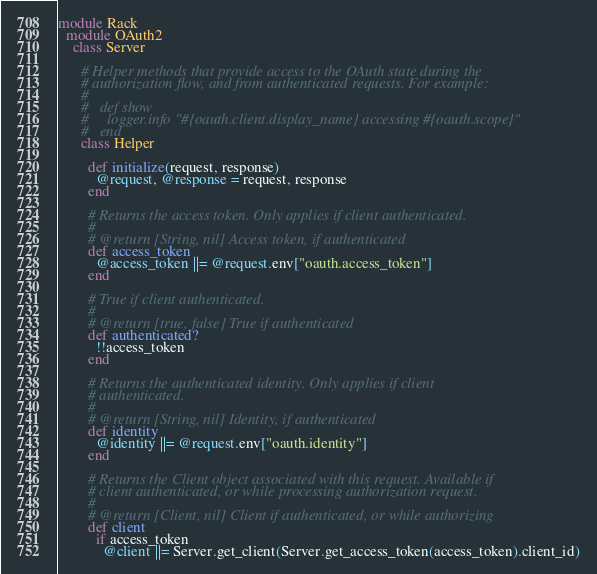<code> <loc_0><loc_0><loc_500><loc_500><_Ruby_>module Rack
  module OAuth2
    class Server

      # Helper methods that provide access to the OAuth state during the
      # authorization flow, and from authenticated requests. For example:
      #
      #   def show
      #     logger.info "#{oauth.client.display_name} accessing #{oauth.scope}"
      #   end
      class Helper

        def initialize(request, response)
          @request, @response = request, response
        end

        # Returns the access token. Only applies if client authenticated.
        #
        # @return [String, nil] Access token, if authenticated
        def access_token
          @access_token ||= @request.env["oauth.access_token"]
        end

        # True if client authenticated.
        #
        # @return [true, false] True if authenticated
        def authenticated?
          !!access_token
        end

        # Returns the authenticated identity. Only applies if client
        # authenticated.
        #
        # @return [String, nil] Identity, if authenticated
        def identity
          @identity ||= @request.env["oauth.identity"]
        end

        # Returns the Client object associated with this request. Available if
        # client authenticated, or while processing authorization request.
        #
        # @return [Client, nil] Client if authenticated, or while authorizing
        def client
          if access_token
            @client ||= Server.get_client(Server.get_access_token(access_token).client_id)</code> 